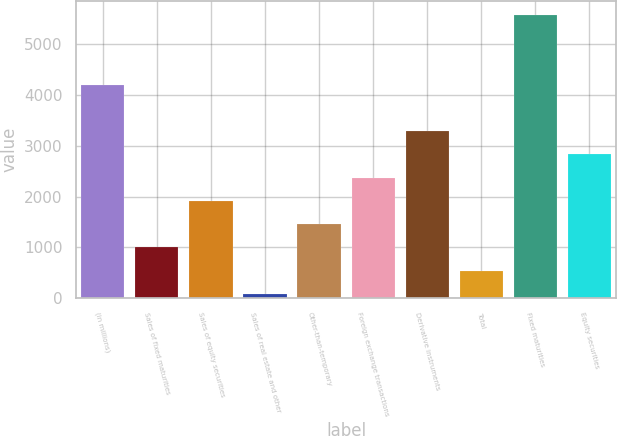<chart> <loc_0><loc_0><loc_500><loc_500><bar_chart><fcel>(in millions)<fcel>Sales of fixed maturities<fcel>Sales of equity securities<fcel>Sales of real estate and other<fcel>Other-than-temporary<fcel>Foreign exchange transactions<fcel>Derivative instruments<fcel>Total<fcel>Fixed maturities<fcel>Equity securities<nl><fcel>4199.2<fcel>1001.6<fcel>1915.2<fcel>88<fcel>1458.4<fcel>2372<fcel>3285.6<fcel>544.8<fcel>5569.6<fcel>2828.8<nl></chart> 